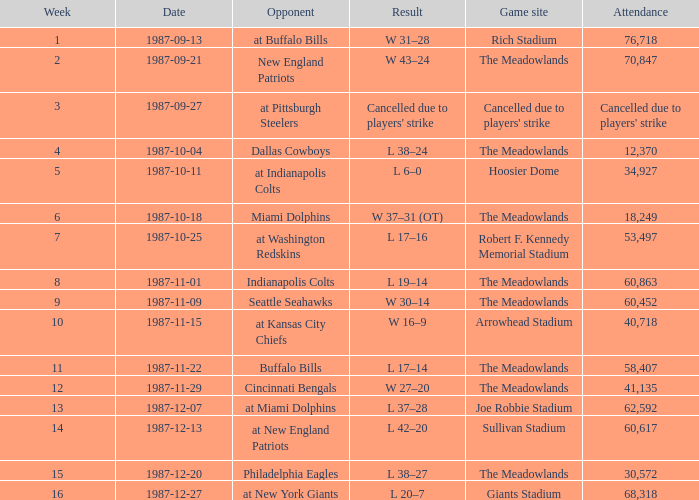Could you help me parse every detail presented in this table? {'header': ['Week', 'Date', 'Opponent', 'Result', 'Game site', 'Attendance'], 'rows': [['1', '1987-09-13', 'at Buffalo Bills', 'W 31–28', 'Rich Stadium', '76,718'], ['2', '1987-09-21', 'New England Patriots', 'W 43–24', 'The Meadowlands', '70,847'], ['3', '1987-09-27', 'at Pittsburgh Steelers', "Cancelled due to players' strike", "Cancelled due to players' strike", "Cancelled due to players' strike"], ['4', '1987-10-04', 'Dallas Cowboys', 'L 38–24', 'The Meadowlands', '12,370'], ['5', '1987-10-11', 'at Indianapolis Colts', 'L 6–0', 'Hoosier Dome', '34,927'], ['6', '1987-10-18', 'Miami Dolphins', 'W 37–31 (OT)', 'The Meadowlands', '18,249'], ['7', '1987-10-25', 'at Washington Redskins', 'L 17–16', 'Robert F. Kennedy Memorial Stadium', '53,497'], ['8', '1987-11-01', 'Indianapolis Colts', 'L 19–14', 'The Meadowlands', '60,863'], ['9', '1987-11-09', 'Seattle Seahawks', 'W 30–14', 'The Meadowlands', '60,452'], ['10', '1987-11-15', 'at Kansas City Chiefs', 'W 16–9', 'Arrowhead Stadium', '40,718'], ['11', '1987-11-22', 'Buffalo Bills', 'L 17–14', 'The Meadowlands', '58,407'], ['12', '1987-11-29', 'Cincinnati Bengals', 'W 27–20', 'The Meadowlands', '41,135'], ['13', '1987-12-07', 'at Miami Dolphins', 'L 37–28', 'Joe Robbie Stadium', '62,592'], ['14', '1987-12-13', 'at New England Patriots', 'L 42–20', 'Sullivan Stadium', '60,617'], ['15', '1987-12-20', 'Philadelphia Eagles', 'L 38–27', 'The Meadowlands', '30,572'], ['16', '1987-12-27', 'at New York Giants', 'L 20–7', 'Giants Stadium', '68,318']]} Who did the Jets play in their pre-week 9 game at the Robert F. Kennedy memorial stadium? At washington redskins. 